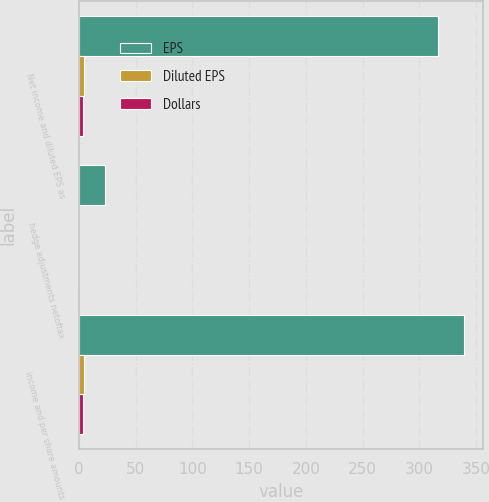Convert chart to OTSL. <chart><loc_0><loc_0><loc_500><loc_500><stacked_bar_chart><ecel><fcel>Net income and diluted EPS as<fcel>hedge adjustments netoftax<fcel>income and per share amounts<nl><fcel>EPS<fcel>316<fcel>23<fcel>339<nl><fcel>Diluted EPS<fcel>4.4<fcel>0.33<fcel>4.73<nl><fcel>Dollars<fcel>3.33<fcel>0.26<fcel>3.92<nl></chart> 